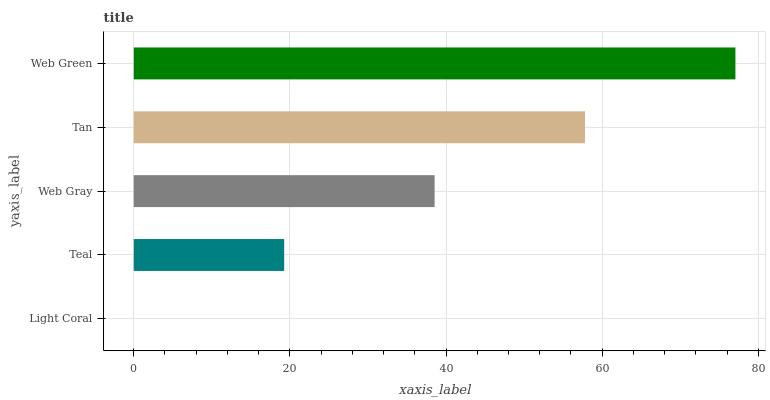Is Light Coral the minimum?
Answer yes or no. Yes. Is Web Green the maximum?
Answer yes or no. Yes. Is Teal the minimum?
Answer yes or no. No. Is Teal the maximum?
Answer yes or no. No. Is Teal greater than Light Coral?
Answer yes or no. Yes. Is Light Coral less than Teal?
Answer yes or no. Yes. Is Light Coral greater than Teal?
Answer yes or no. No. Is Teal less than Light Coral?
Answer yes or no. No. Is Web Gray the high median?
Answer yes or no. Yes. Is Web Gray the low median?
Answer yes or no. Yes. Is Tan the high median?
Answer yes or no. No. Is Teal the low median?
Answer yes or no. No. 